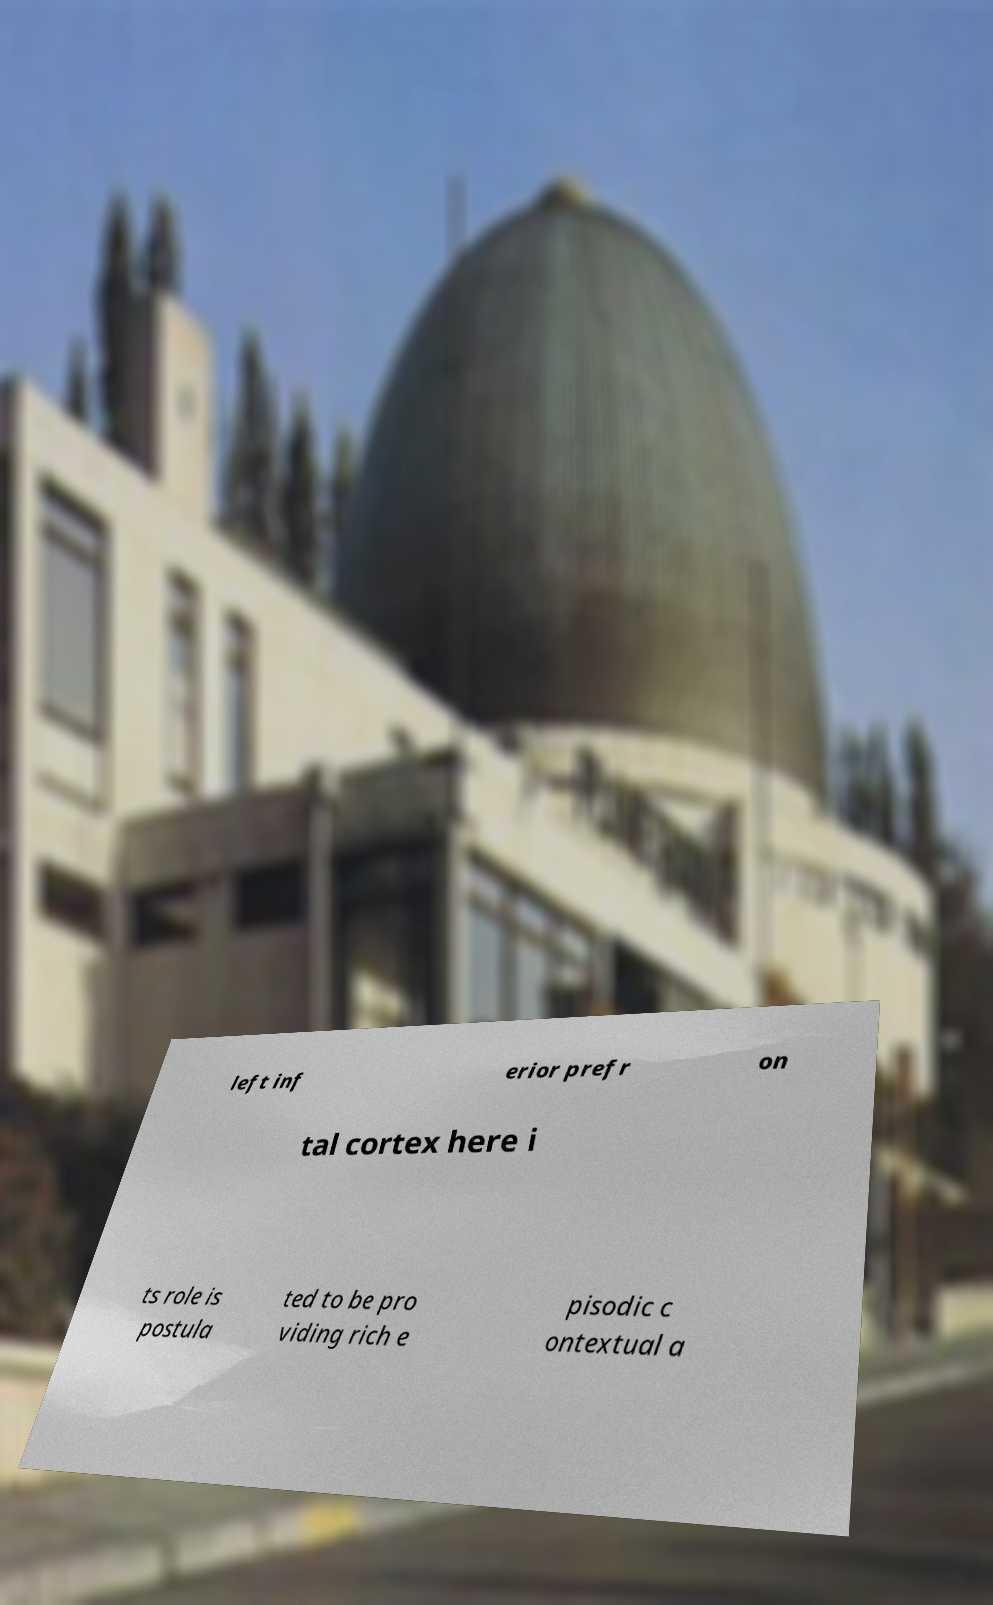Please identify and transcribe the text found in this image. left inf erior prefr on tal cortex here i ts role is postula ted to be pro viding rich e pisodic c ontextual a 